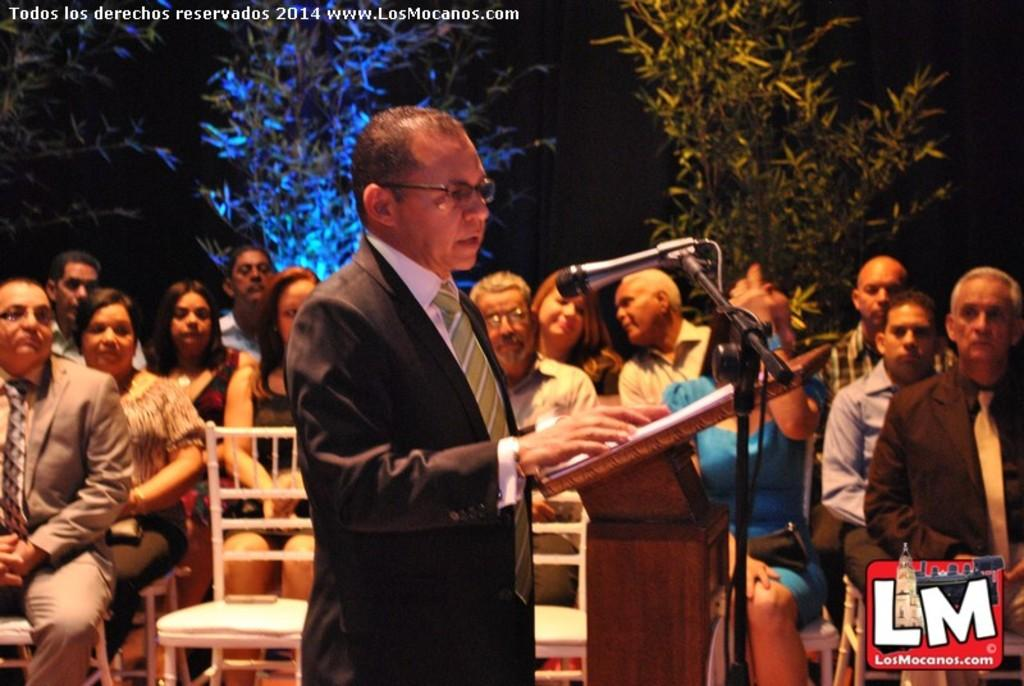What is the man in the image doing? The man is standing in the image and holding a microphone. What might the man be using the microphone for? The man might be using the microphone for speaking or presenting, as he is near a podium. What can be seen in the background of the image? There is a group of people sitting in chairs and a tree visible in the background. What type of stove is visible in the image? There is no stove present in the image. How many cushions are on the chairs in the background? The image does not provide enough detail to determine the number of cushions on the chairs in the background. 